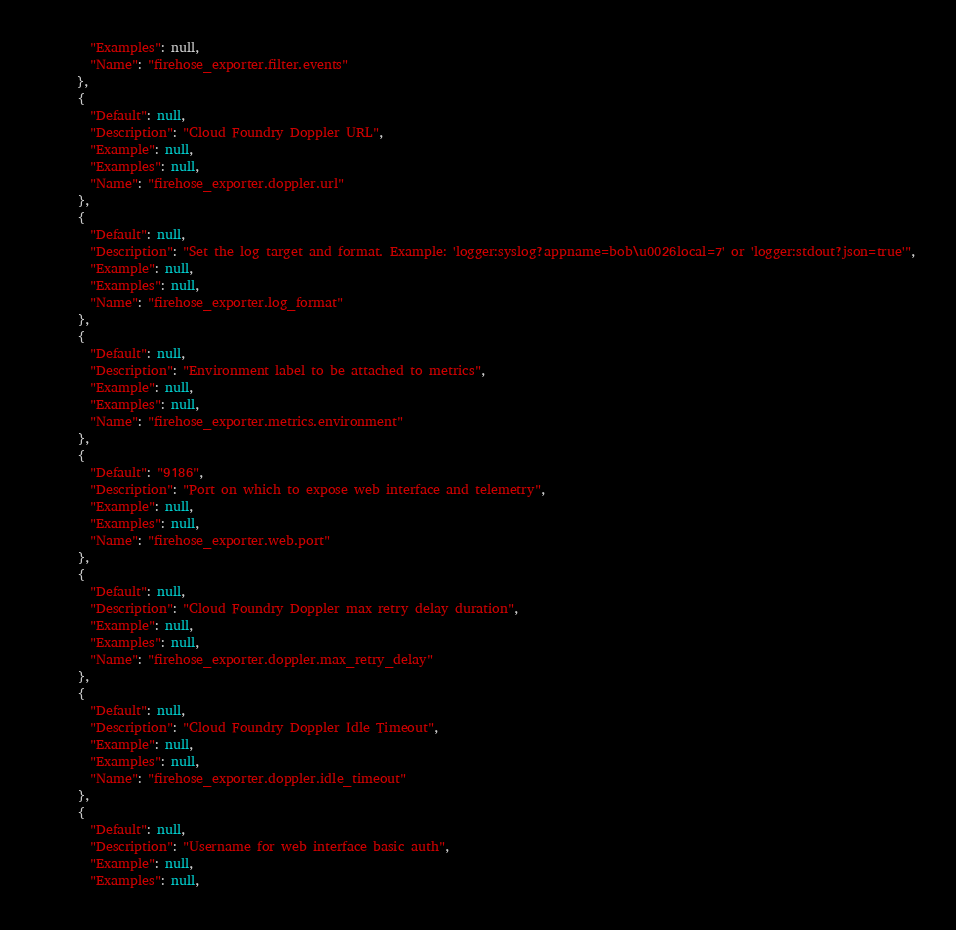Convert code to text. <code><loc_0><loc_0><loc_500><loc_500><_YAML_>        "Examples": null,
        "Name": "firehose_exporter.filter.events"
      },
      {
        "Default": null,
        "Description": "Cloud Foundry Doppler URL",
        "Example": null,
        "Examples": null,
        "Name": "firehose_exporter.doppler.url"
      },
      {
        "Default": null,
        "Description": "Set the log target and format. Example: 'logger:syslog?appname=bob\u0026local=7' or 'logger:stdout?json=true'",
        "Example": null,
        "Examples": null,
        "Name": "firehose_exporter.log_format"
      },
      {
        "Default": null,
        "Description": "Environment label to be attached to metrics",
        "Example": null,
        "Examples": null,
        "Name": "firehose_exporter.metrics.environment"
      },
      {
        "Default": "9186",
        "Description": "Port on which to expose web interface and telemetry",
        "Example": null,
        "Examples": null,
        "Name": "firehose_exporter.web.port"
      },
      {
        "Default": null,
        "Description": "Cloud Foundry Doppler max retry delay duration",
        "Example": null,
        "Examples": null,
        "Name": "firehose_exporter.doppler.max_retry_delay"
      },
      {
        "Default": null,
        "Description": "Cloud Foundry Doppler Idle Timeout",
        "Example": null,
        "Examples": null,
        "Name": "firehose_exporter.doppler.idle_timeout"
      },
      {
        "Default": null,
        "Description": "Username for web interface basic auth",
        "Example": null,
        "Examples": null,</code> 